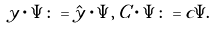Convert formula to latex. <formula><loc_0><loc_0><loc_500><loc_500>y \cdot \Psi \colon = \hat { y } \cdot \Psi , \, C \cdot \Psi \colon = c \Psi . \\</formula> 